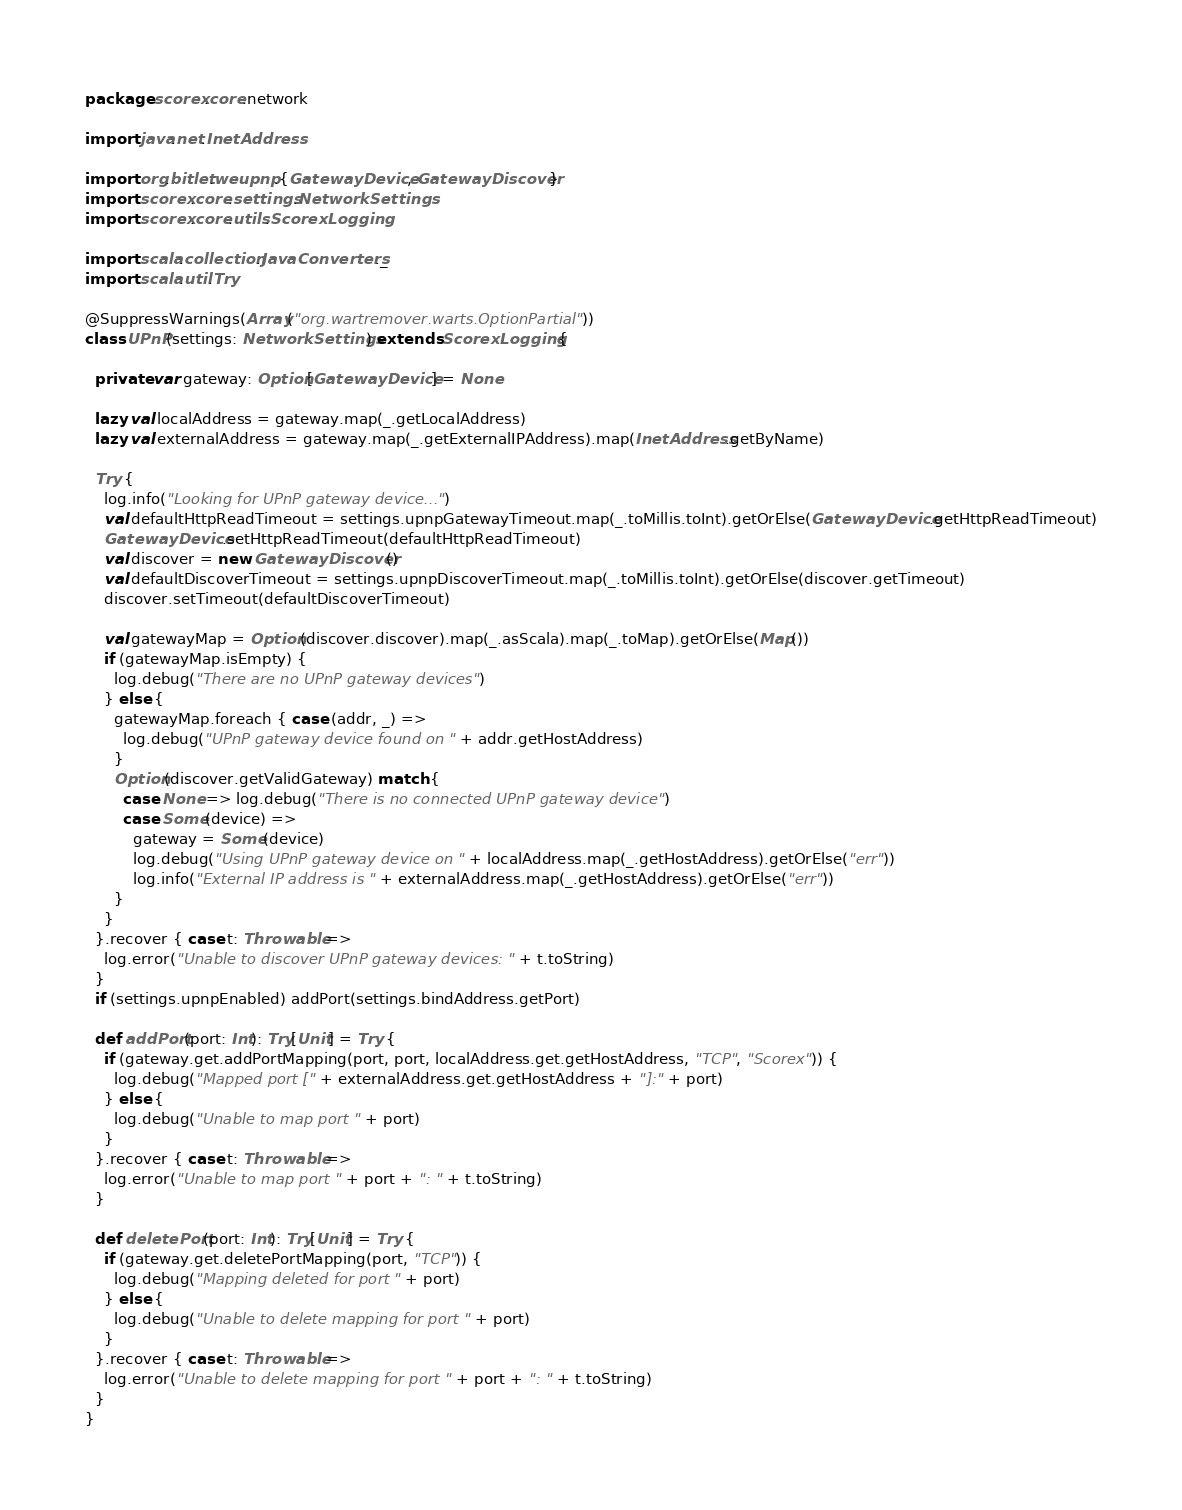Convert code to text. <code><loc_0><loc_0><loc_500><loc_500><_Scala_>package scorex.core.network

import java.net.InetAddress

import org.bitlet.weupnp.{GatewayDevice, GatewayDiscover}
import scorex.core.settings.NetworkSettings
import scorex.core.utils.ScorexLogging

import scala.collection.JavaConverters._
import scala.util.Try

@SuppressWarnings(Array("org.wartremover.warts.OptionPartial"))
class UPnP(settings: NetworkSettings) extends ScorexLogging {

  private var gateway: Option[GatewayDevice] = None

  lazy val localAddress = gateway.map(_.getLocalAddress)
  lazy val externalAddress = gateway.map(_.getExternalIPAddress).map(InetAddress.getByName)

  Try {
    log.info("Looking for UPnP gateway device...")
    val defaultHttpReadTimeout = settings.upnpGatewayTimeout.map(_.toMillis.toInt).getOrElse(GatewayDevice.getHttpReadTimeout)
    GatewayDevice.setHttpReadTimeout(defaultHttpReadTimeout)
    val discover = new GatewayDiscover()
    val defaultDiscoverTimeout = settings.upnpDiscoverTimeout.map(_.toMillis.toInt).getOrElse(discover.getTimeout)
    discover.setTimeout(defaultDiscoverTimeout)

    val gatewayMap = Option(discover.discover).map(_.asScala).map(_.toMap).getOrElse(Map())
    if (gatewayMap.isEmpty) {
      log.debug("There are no UPnP gateway devices")
    } else {
      gatewayMap.foreach { case (addr, _) =>
        log.debug("UPnP gateway device found on " + addr.getHostAddress)
      }
      Option(discover.getValidGateway) match {
        case None => log.debug("There is no connected UPnP gateway device")
        case Some(device) =>
          gateway = Some(device)
          log.debug("Using UPnP gateway device on " + localAddress.map(_.getHostAddress).getOrElse("err"))
          log.info("External IP address is " + externalAddress.map(_.getHostAddress).getOrElse("err"))
      }
    }
  }.recover { case t: Throwable =>
    log.error("Unable to discover UPnP gateway devices: " + t.toString)
  }
  if (settings.upnpEnabled) addPort(settings.bindAddress.getPort)

  def addPort(port: Int): Try[Unit] = Try {
    if (gateway.get.addPortMapping(port, port, localAddress.get.getHostAddress, "TCP", "Scorex")) {
      log.debug("Mapped port [" + externalAddress.get.getHostAddress + "]:" + port)
    } else {
      log.debug("Unable to map port " + port)
    }
  }.recover { case t: Throwable =>
    log.error("Unable to map port " + port + ": " + t.toString)
  }

  def deletePort(port: Int): Try[Unit] = Try {
    if (gateway.get.deletePortMapping(port, "TCP")) {
      log.debug("Mapping deleted for port " + port)
    } else {
      log.debug("Unable to delete mapping for port " + port)
    }
  }.recover { case t: Throwable =>
    log.error("Unable to delete mapping for port " + port + ": " + t.toString)
  }
}
</code> 